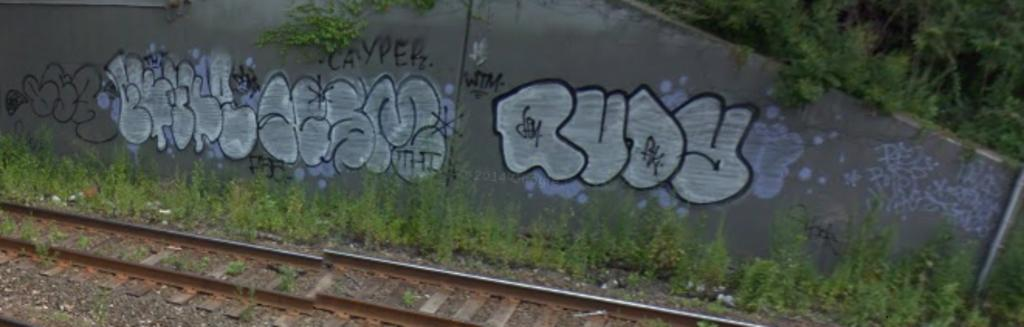<image>
Share a concise interpretation of the image provided. An overgrown train track has graffiti on a concrete wall that says Rudy. 